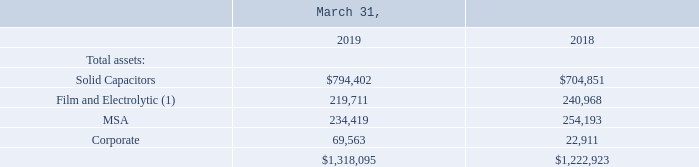The following tables summarize information for operating income (loss), depreciation and amortization, restructuring charges, gain (loss) on write down and disposal of long-lived assets, and capital expenditures by reportable segment for the fiscal years ended 2019, 2018 and 2017 and total assets by reportable segment for the fiscal years ended 2019 and 2018 (amounts in thousands): The following tables summarize information for operating income (loss), depreciation and amortization, restructuring charges, gain (loss) on write down and disposal of long-lived assets, and capital expenditures by reportable segment for the fiscal years ended 2019, 2018 and 2017 and total assets by reportable segment for the fiscal years ended 2019 and 2018 (amounts in thousands):
(1) March 31, 2018 adjusted due to the adoption of ASC 606.
Which years does the table provide information for total assets by reportable segment? 2019, 2018. What were the total assets in MSA in 2019?
Answer scale should be: thousand. 234,419. What were the total Corporate assets in 2018?
Answer scale should be: thousand. 22,911. What was the change in total assets in Solid Capacitors between 2018 and 2019?
Answer scale should be: thousand. 794,402-704,851
Answer: 89551. What was the change in total assets in MSA between 2018 and 2019?
Answer scale should be: thousand. 234,419-254,193
Answer: -19774. What was the percentage change total amount of assets across all segments between 2018 and 2019?
Answer scale should be: percent. (1,318,095-1,222,923)/1,222,923
Answer: 7.78. 